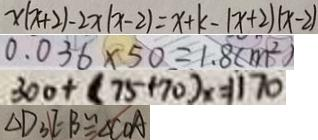<formula> <loc_0><loc_0><loc_500><loc_500>x ( x + 2 ) - 2 x ( x - 2 ) = x + k - ( x + 2 ) ( x - 2 ) 
 0 . 0 3 6 \times 5 0 = 1 . 8 ( m ^ { 2 } ) 
 3 0 0 + ( 7 5 + 7 0 ) _ { x } = 1 1 7 0 
 \Delta D _ { 3 } E : B \cong \Delta C O A</formula> 